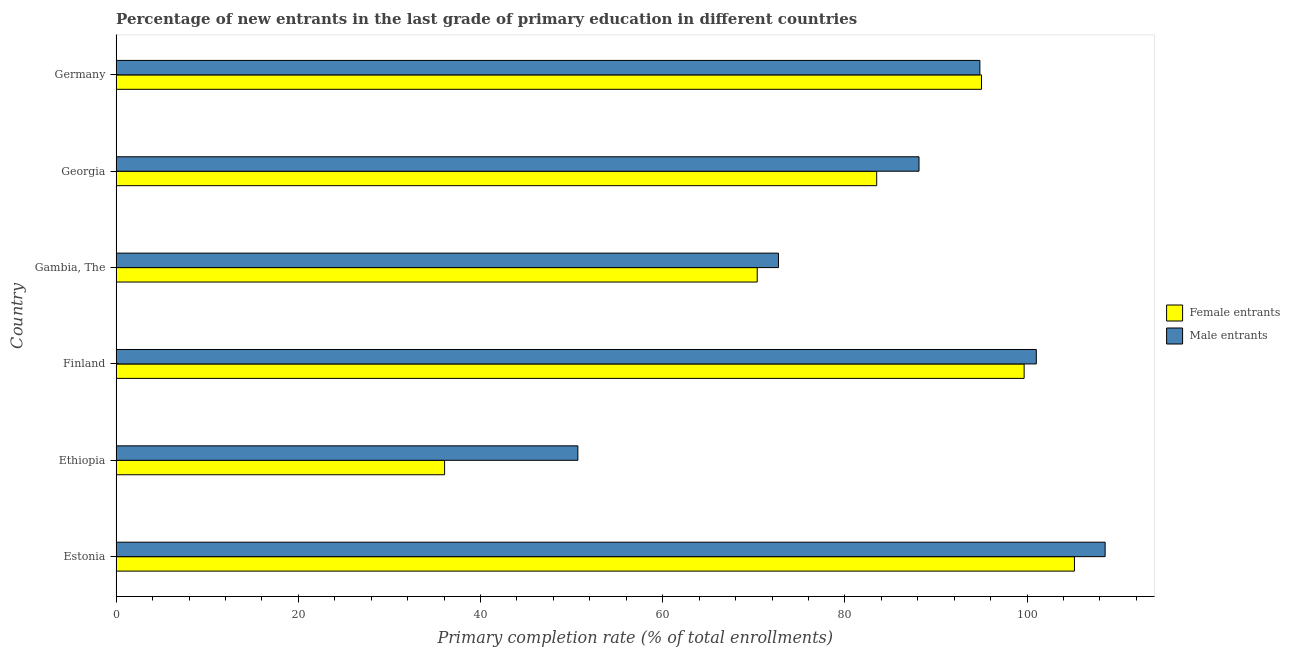How many different coloured bars are there?
Provide a short and direct response. 2. How many groups of bars are there?
Your answer should be very brief. 6. How many bars are there on the 6th tick from the bottom?
Provide a succinct answer. 2. What is the label of the 5th group of bars from the top?
Provide a short and direct response. Ethiopia. What is the primary completion rate of female entrants in Finland?
Provide a succinct answer. 99.68. Across all countries, what is the maximum primary completion rate of male entrants?
Give a very brief answer. 108.57. Across all countries, what is the minimum primary completion rate of male entrants?
Keep it short and to the point. 50.69. In which country was the primary completion rate of female entrants maximum?
Keep it short and to the point. Estonia. In which country was the primary completion rate of female entrants minimum?
Make the answer very short. Ethiopia. What is the total primary completion rate of male entrants in the graph?
Keep it short and to the point. 515.95. What is the difference between the primary completion rate of male entrants in Ethiopia and that in Georgia?
Offer a very short reply. -37.45. What is the difference between the primary completion rate of female entrants in Gambia, The and the primary completion rate of male entrants in Germany?
Ensure brevity in your answer.  -24.44. What is the average primary completion rate of female entrants per country?
Ensure brevity in your answer.  81.64. What is the difference between the primary completion rate of female entrants and primary completion rate of male entrants in Gambia, The?
Offer a very short reply. -2.33. In how many countries, is the primary completion rate of female entrants greater than 68 %?
Your answer should be very brief. 5. What is the ratio of the primary completion rate of female entrants in Ethiopia to that in Finland?
Give a very brief answer. 0.36. Is the primary completion rate of female entrants in Estonia less than that in Germany?
Your answer should be compact. No. Is the difference between the primary completion rate of male entrants in Estonia and Finland greater than the difference between the primary completion rate of female entrants in Estonia and Finland?
Your answer should be compact. Yes. What is the difference between the highest and the second highest primary completion rate of female entrants?
Provide a short and direct response. 5.52. What is the difference between the highest and the lowest primary completion rate of female entrants?
Offer a very short reply. 69.14. What does the 1st bar from the top in Ethiopia represents?
Provide a succinct answer. Male entrants. What does the 1st bar from the bottom in Ethiopia represents?
Give a very brief answer. Female entrants. How many bars are there?
Provide a succinct answer. 12. Are all the bars in the graph horizontal?
Ensure brevity in your answer.  Yes. How many countries are there in the graph?
Your answer should be compact. 6. What is the difference between two consecutive major ticks on the X-axis?
Give a very brief answer. 20. Are the values on the major ticks of X-axis written in scientific E-notation?
Offer a very short reply. No. Does the graph contain any zero values?
Your answer should be compact. No. Does the graph contain grids?
Make the answer very short. No. How are the legend labels stacked?
Provide a short and direct response. Vertical. What is the title of the graph?
Give a very brief answer. Percentage of new entrants in the last grade of primary education in different countries. What is the label or title of the X-axis?
Your answer should be compact. Primary completion rate (% of total enrollments). What is the label or title of the Y-axis?
Keep it short and to the point. Country. What is the Primary completion rate (% of total enrollments) of Female entrants in Estonia?
Keep it short and to the point. 105.2. What is the Primary completion rate (% of total enrollments) of Male entrants in Estonia?
Your answer should be compact. 108.57. What is the Primary completion rate (% of total enrollments) in Female entrants in Ethiopia?
Your answer should be compact. 36.06. What is the Primary completion rate (% of total enrollments) of Male entrants in Ethiopia?
Give a very brief answer. 50.69. What is the Primary completion rate (% of total enrollments) in Female entrants in Finland?
Your answer should be compact. 99.68. What is the Primary completion rate (% of total enrollments) of Male entrants in Finland?
Your answer should be very brief. 101.02. What is the Primary completion rate (% of total enrollments) of Female entrants in Gambia, The?
Your response must be concise. 70.38. What is the Primary completion rate (% of total enrollments) in Male entrants in Gambia, The?
Your answer should be very brief. 72.71. What is the Primary completion rate (% of total enrollments) in Female entrants in Georgia?
Offer a very short reply. 83.49. What is the Primary completion rate (% of total enrollments) of Male entrants in Georgia?
Give a very brief answer. 88.14. What is the Primary completion rate (% of total enrollments) of Female entrants in Germany?
Ensure brevity in your answer.  95. What is the Primary completion rate (% of total enrollments) of Male entrants in Germany?
Provide a succinct answer. 94.82. Across all countries, what is the maximum Primary completion rate (% of total enrollments) in Female entrants?
Provide a succinct answer. 105.2. Across all countries, what is the maximum Primary completion rate (% of total enrollments) of Male entrants?
Provide a short and direct response. 108.57. Across all countries, what is the minimum Primary completion rate (% of total enrollments) in Female entrants?
Offer a terse response. 36.06. Across all countries, what is the minimum Primary completion rate (% of total enrollments) of Male entrants?
Ensure brevity in your answer.  50.69. What is the total Primary completion rate (% of total enrollments) of Female entrants in the graph?
Provide a succinct answer. 489.81. What is the total Primary completion rate (% of total enrollments) of Male entrants in the graph?
Your answer should be compact. 515.95. What is the difference between the Primary completion rate (% of total enrollments) in Female entrants in Estonia and that in Ethiopia?
Give a very brief answer. 69.14. What is the difference between the Primary completion rate (% of total enrollments) in Male entrants in Estonia and that in Ethiopia?
Ensure brevity in your answer.  57.88. What is the difference between the Primary completion rate (% of total enrollments) of Female entrants in Estonia and that in Finland?
Your answer should be compact. 5.52. What is the difference between the Primary completion rate (% of total enrollments) of Male entrants in Estonia and that in Finland?
Provide a short and direct response. 7.56. What is the difference between the Primary completion rate (% of total enrollments) of Female entrants in Estonia and that in Gambia, The?
Provide a succinct answer. 34.82. What is the difference between the Primary completion rate (% of total enrollments) of Male entrants in Estonia and that in Gambia, The?
Offer a very short reply. 35.86. What is the difference between the Primary completion rate (% of total enrollments) of Female entrants in Estonia and that in Georgia?
Make the answer very short. 21.71. What is the difference between the Primary completion rate (% of total enrollments) in Male entrants in Estonia and that in Georgia?
Provide a short and direct response. 20.43. What is the difference between the Primary completion rate (% of total enrollments) in Female entrants in Estonia and that in Germany?
Your answer should be very brief. 10.2. What is the difference between the Primary completion rate (% of total enrollments) of Male entrants in Estonia and that in Germany?
Your answer should be very brief. 13.75. What is the difference between the Primary completion rate (% of total enrollments) in Female entrants in Ethiopia and that in Finland?
Provide a short and direct response. -63.62. What is the difference between the Primary completion rate (% of total enrollments) of Male entrants in Ethiopia and that in Finland?
Your response must be concise. -50.33. What is the difference between the Primary completion rate (% of total enrollments) in Female entrants in Ethiopia and that in Gambia, The?
Provide a succinct answer. -34.32. What is the difference between the Primary completion rate (% of total enrollments) in Male entrants in Ethiopia and that in Gambia, The?
Make the answer very short. -22.02. What is the difference between the Primary completion rate (% of total enrollments) of Female entrants in Ethiopia and that in Georgia?
Your answer should be compact. -47.44. What is the difference between the Primary completion rate (% of total enrollments) in Male entrants in Ethiopia and that in Georgia?
Offer a very short reply. -37.45. What is the difference between the Primary completion rate (% of total enrollments) in Female entrants in Ethiopia and that in Germany?
Keep it short and to the point. -58.94. What is the difference between the Primary completion rate (% of total enrollments) in Male entrants in Ethiopia and that in Germany?
Provide a succinct answer. -44.13. What is the difference between the Primary completion rate (% of total enrollments) in Female entrants in Finland and that in Gambia, The?
Make the answer very short. 29.3. What is the difference between the Primary completion rate (% of total enrollments) in Male entrants in Finland and that in Gambia, The?
Provide a succinct answer. 28.31. What is the difference between the Primary completion rate (% of total enrollments) in Female entrants in Finland and that in Georgia?
Your answer should be very brief. 16.18. What is the difference between the Primary completion rate (% of total enrollments) of Male entrants in Finland and that in Georgia?
Provide a short and direct response. 12.88. What is the difference between the Primary completion rate (% of total enrollments) in Female entrants in Finland and that in Germany?
Give a very brief answer. 4.68. What is the difference between the Primary completion rate (% of total enrollments) in Male entrants in Finland and that in Germany?
Keep it short and to the point. 6.2. What is the difference between the Primary completion rate (% of total enrollments) of Female entrants in Gambia, The and that in Georgia?
Offer a terse response. -13.12. What is the difference between the Primary completion rate (% of total enrollments) of Male entrants in Gambia, The and that in Georgia?
Offer a very short reply. -15.43. What is the difference between the Primary completion rate (% of total enrollments) of Female entrants in Gambia, The and that in Germany?
Offer a very short reply. -24.62. What is the difference between the Primary completion rate (% of total enrollments) of Male entrants in Gambia, The and that in Germany?
Your answer should be very brief. -22.11. What is the difference between the Primary completion rate (% of total enrollments) of Female entrants in Georgia and that in Germany?
Offer a very short reply. -11.5. What is the difference between the Primary completion rate (% of total enrollments) in Male entrants in Georgia and that in Germany?
Your answer should be very brief. -6.68. What is the difference between the Primary completion rate (% of total enrollments) of Female entrants in Estonia and the Primary completion rate (% of total enrollments) of Male entrants in Ethiopia?
Offer a very short reply. 54.51. What is the difference between the Primary completion rate (% of total enrollments) of Female entrants in Estonia and the Primary completion rate (% of total enrollments) of Male entrants in Finland?
Your answer should be compact. 4.18. What is the difference between the Primary completion rate (% of total enrollments) of Female entrants in Estonia and the Primary completion rate (% of total enrollments) of Male entrants in Gambia, The?
Your response must be concise. 32.49. What is the difference between the Primary completion rate (% of total enrollments) of Female entrants in Estonia and the Primary completion rate (% of total enrollments) of Male entrants in Georgia?
Keep it short and to the point. 17.06. What is the difference between the Primary completion rate (% of total enrollments) of Female entrants in Estonia and the Primary completion rate (% of total enrollments) of Male entrants in Germany?
Provide a short and direct response. 10.38. What is the difference between the Primary completion rate (% of total enrollments) in Female entrants in Ethiopia and the Primary completion rate (% of total enrollments) in Male entrants in Finland?
Keep it short and to the point. -64.96. What is the difference between the Primary completion rate (% of total enrollments) of Female entrants in Ethiopia and the Primary completion rate (% of total enrollments) of Male entrants in Gambia, The?
Offer a terse response. -36.65. What is the difference between the Primary completion rate (% of total enrollments) of Female entrants in Ethiopia and the Primary completion rate (% of total enrollments) of Male entrants in Georgia?
Ensure brevity in your answer.  -52.08. What is the difference between the Primary completion rate (% of total enrollments) in Female entrants in Ethiopia and the Primary completion rate (% of total enrollments) in Male entrants in Germany?
Give a very brief answer. -58.76. What is the difference between the Primary completion rate (% of total enrollments) in Female entrants in Finland and the Primary completion rate (% of total enrollments) in Male entrants in Gambia, The?
Keep it short and to the point. 26.97. What is the difference between the Primary completion rate (% of total enrollments) in Female entrants in Finland and the Primary completion rate (% of total enrollments) in Male entrants in Georgia?
Offer a terse response. 11.54. What is the difference between the Primary completion rate (% of total enrollments) of Female entrants in Finland and the Primary completion rate (% of total enrollments) of Male entrants in Germany?
Provide a short and direct response. 4.86. What is the difference between the Primary completion rate (% of total enrollments) in Female entrants in Gambia, The and the Primary completion rate (% of total enrollments) in Male entrants in Georgia?
Give a very brief answer. -17.76. What is the difference between the Primary completion rate (% of total enrollments) in Female entrants in Gambia, The and the Primary completion rate (% of total enrollments) in Male entrants in Germany?
Keep it short and to the point. -24.44. What is the difference between the Primary completion rate (% of total enrollments) in Female entrants in Georgia and the Primary completion rate (% of total enrollments) in Male entrants in Germany?
Provide a succinct answer. -11.33. What is the average Primary completion rate (% of total enrollments) of Female entrants per country?
Make the answer very short. 81.64. What is the average Primary completion rate (% of total enrollments) of Male entrants per country?
Provide a succinct answer. 85.99. What is the difference between the Primary completion rate (% of total enrollments) of Female entrants and Primary completion rate (% of total enrollments) of Male entrants in Estonia?
Offer a terse response. -3.37. What is the difference between the Primary completion rate (% of total enrollments) of Female entrants and Primary completion rate (% of total enrollments) of Male entrants in Ethiopia?
Make the answer very short. -14.63. What is the difference between the Primary completion rate (% of total enrollments) of Female entrants and Primary completion rate (% of total enrollments) of Male entrants in Finland?
Give a very brief answer. -1.34. What is the difference between the Primary completion rate (% of total enrollments) in Female entrants and Primary completion rate (% of total enrollments) in Male entrants in Gambia, The?
Give a very brief answer. -2.33. What is the difference between the Primary completion rate (% of total enrollments) in Female entrants and Primary completion rate (% of total enrollments) in Male entrants in Georgia?
Your answer should be very brief. -4.65. What is the difference between the Primary completion rate (% of total enrollments) in Female entrants and Primary completion rate (% of total enrollments) in Male entrants in Germany?
Give a very brief answer. 0.18. What is the ratio of the Primary completion rate (% of total enrollments) in Female entrants in Estonia to that in Ethiopia?
Your response must be concise. 2.92. What is the ratio of the Primary completion rate (% of total enrollments) in Male entrants in Estonia to that in Ethiopia?
Ensure brevity in your answer.  2.14. What is the ratio of the Primary completion rate (% of total enrollments) of Female entrants in Estonia to that in Finland?
Your answer should be compact. 1.06. What is the ratio of the Primary completion rate (% of total enrollments) in Male entrants in Estonia to that in Finland?
Keep it short and to the point. 1.07. What is the ratio of the Primary completion rate (% of total enrollments) in Female entrants in Estonia to that in Gambia, The?
Give a very brief answer. 1.49. What is the ratio of the Primary completion rate (% of total enrollments) in Male entrants in Estonia to that in Gambia, The?
Give a very brief answer. 1.49. What is the ratio of the Primary completion rate (% of total enrollments) of Female entrants in Estonia to that in Georgia?
Keep it short and to the point. 1.26. What is the ratio of the Primary completion rate (% of total enrollments) of Male entrants in Estonia to that in Georgia?
Your answer should be compact. 1.23. What is the ratio of the Primary completion rate (% of total enrollments) in Female entrants in Estonia to that in Germany?
Your response must be concise. 1.11. What is the ratio of the Primary completion rate (% of total enrollments) of Male entrants in Estonia to that in Germany?
Keep it short and to the point. 1.15. What is the ratio of the Primary completion rate (% of total enrollments) in Female entrants in Ethiopia to that in Finland?
Your answer should be compact. 0.36. What is the ratio of the Primary completion rate (% of total enrollments) in Male entrants in Ethiopia to that in Finland?
Provide a succinct answer. 0.5. What is the ratio of the Primary completion rate (% of total enrollments) of Female entrants in Ethiopia to that in Gambia, The?
Your answer should be very brief. 0.51. What is the ratio of the Primary completion rate (% of total enrollments) of Male entrants in Ethiopia to that in Gambia, The?
Make the answer very short. 0.7. What is the ratio of the Primary completion rate (% of total enrollments) of Female entrants in Ethiopia to that in Georgia?
Provide a succinct answer. 0.43. What is the ratio of the Primary completion rate (% of total enrollments) of Male entrants in Ethiopia to that in Georgia?
Keep it short and to the point. 0.58. What is the ratio of the Primary completion rate (% of total enrollments) in Female entrants in Ethiopia to that in Germany?
Provide a succinct answer. 0.38. What is the ratio of the Primary completion rate (% of total enrollments) of Male entrants in Ethiopia to that in Germany?
Make the answer very short. 0.53. What is the ratio of the Primary completion rate (% of total enrollments) of Female entrants in Finland to that in Gambia, The?
Ensure brevity in your answer.  1.42. What is the ratio of the Primary completion rate (% of total enrollments) in Male entrants in Finland to that in Gambia, The?
Offer a terse response. 1.39. What is the ratio of the Primary completion rate (% of total enrollments) of Female entrants in Finland to that in Georgia?
Your response must be concise. 1.19. What is the ratio of the Primary completion rate (% of total enrollments) of Male entrants in Finland to that in Georgia?
Ensure brevity in your answer.  1.15. What is the ratio of the Primary completion rate (% of total enrollments) in Female entrants in Finland to that in Germany?
Provide a short and direct response. 1.05. What is the ratio of the Primary completion rate (% of total enrollments) in Male entrants in Finland to that in Germany?
Make the answer very short. 1.07. What is the ratio of the Primary completion rate (% of total enrollments) of Female entrants in Gambia, The to that in Georgia?
Provide a short and direct response. 0.84. What is the ratio of the Primary completion rate (% of total enrollments) of Male entrants in Gambia, The to that in Georgia?
Keep it short and to the point. 0.82. What is the ratio of the Primary completion rate (% of total enrollments) in Female entrants in Gambia, The to that in Germany?
Make the answer very short. 0.74. What is the ratio of the Primary completion rate (% of total enrollments) of Male entrants in Gambia, The to that in Germany?
Ensure brevity in your answer.  0.77. What is the ratio of the Primary completion rate (% of total enrollments) in Female entrants in Georgia to that in Germany?
Offer a terse response. 0.88. What is the ratio of the Primary completion rate (% of total enrollments) of Male entrants in Georgia to that in Germany?
Keep it short and to the point. 0.93. What is the difference between the highest and the second highest Primary completion rate (% of total enrollments) in Female entrants?
Give a very brief answer. 5.52. What is the difference between the highest and the second highest Primary completion rate (% of total enrollments) in Male entrants?
Your response must be concise. 7.56. What is the difference between the highest and the lowest Primary completion rate (% of total enrollments) in Female entrants?
Your answer should be compact. 69.14. What is the difference between the highest and the lowest Primary completion rate (% of total enrollments) of Male entrants?
Offer a terse response. 57.88. 